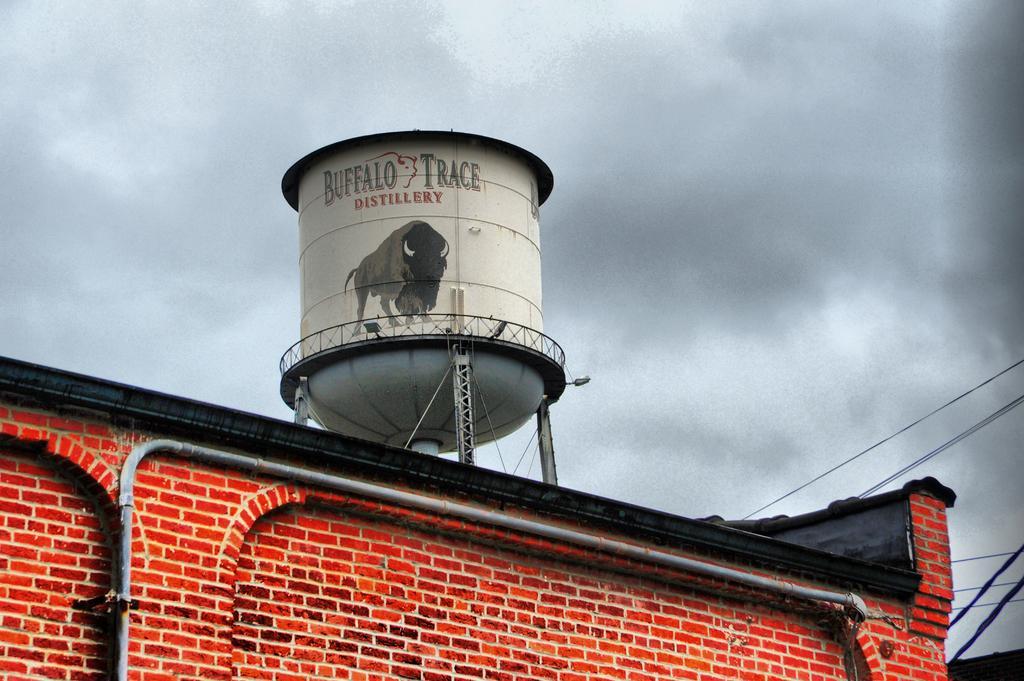Describe this image in one or two sentences. In the foreground of the image we can see a red color wall and a pipe. In the middle of the image we can a big tin on which some text and animal figure is there. On the top of the image we can see the sky. 